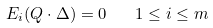Convert formula to latex. <formula><loc_0><loc_0><loc_500><loc_500>E _ { i } ( Q \cdot \Delta ) = 0 \quad 1 \leq i \leq m</formula> 